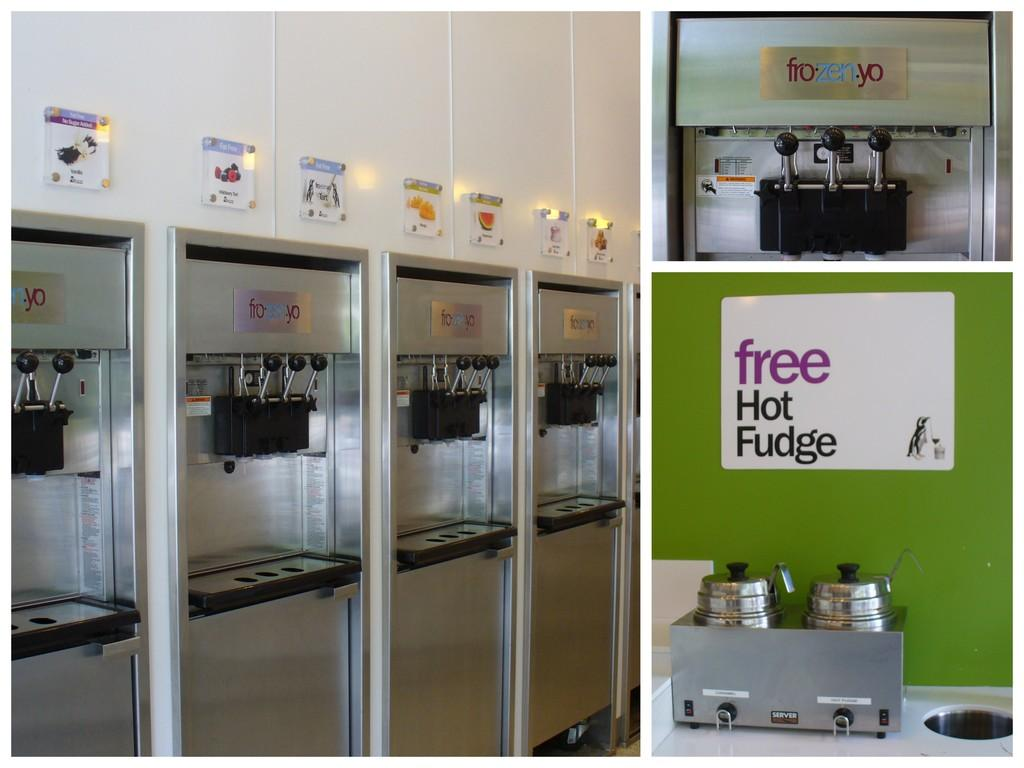<image>
Create a compact narrative representing the image presented. A sign that says "free Hot Fudge" is stuck to the wall. 